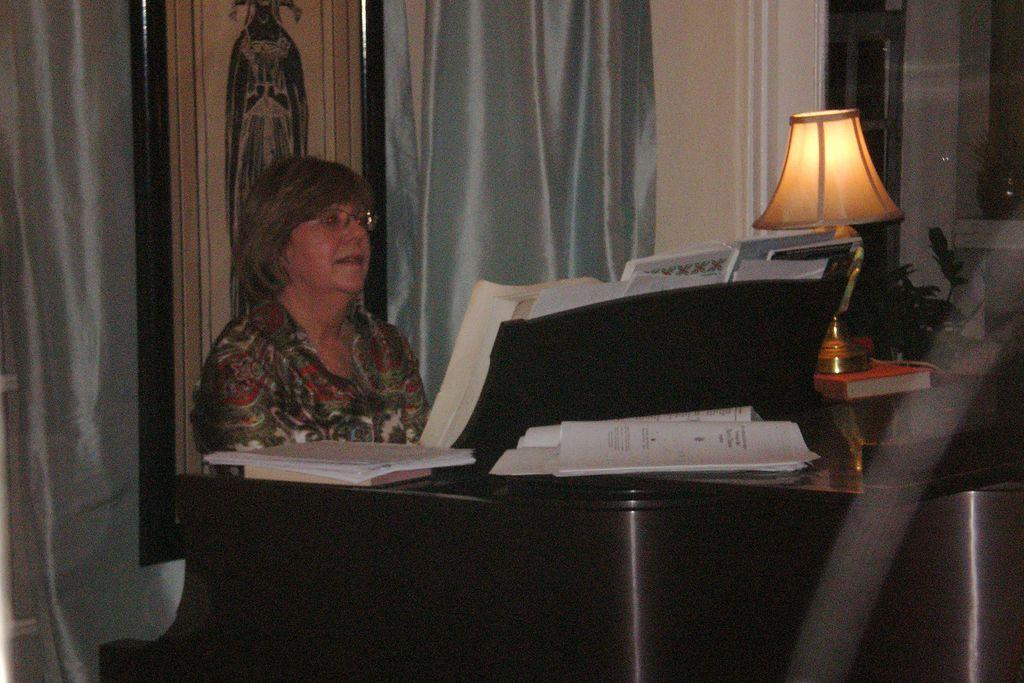What is the woman doing in the image? The woman is sitting on a piano in the image. What object can be seen in the image that provides light? There is a table lamp in the image. How is the table lamp positioned in the image? The table lamp is placed on a book in the image. What type of window treatment is present in the image? There is a curtain on a window in the image. What type of dinosaurs can be seen in the image? There are no dinosaurs present in the image. In which country is the scene in the image taking place? The location of the scene in the image is not specified, so it cannot be determined which country it is in. 